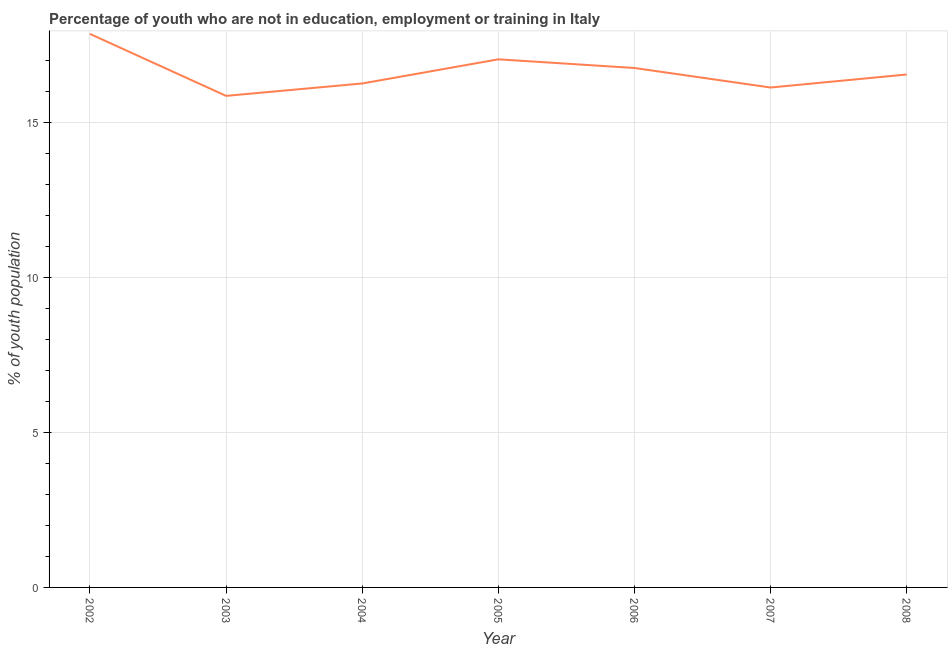What is the unemployed youth population in 2008?
Offer a very short reply. 16.56. Across all years, what is the maximum unemployed youth population?
Your answer should be compact. 17.87. Across all years, what is the minimum unemployed youth population?
Make the answer very short. 15.87. In which year was the unemployed youth population minimum?
Give a very brief answer. 2003. What is the sum of the unemployed youth population?
Offer a terse response. 116.53. What is the difference between the unemployed youth population in 2002 and 2005?
Your response must be concise. 0.82. What is the average unemployed youth population per year?
Give a very brief answer. 16.65. What is the median unemployed youth population?
Provide a succinct answer. 16.56. In how many years, is the unemployed youth population greater than 11 %?
Offer a very short reply. 7. Do a majority of the years between 2004 and 2002 (inclusive) have unemployed youth population greater than 11 %?
Ensure brevity in your answer.  No. What is the ratio of the unemployed youth population in 2005 to that in 2006?
Your response must be concise. 1.02. Is the unemployed youth population in 2005 less than that in 2007?
Keep it short and to the point. No. Is the difference between the unemployed youth population in 2002 and 2007 greater than the difference between any two years?
Keep it short and to the point. No. What is the difference between the highest and the second highest unemployed youth population?
Offer a very short reply. 0.82. Is the sum of the unemployed youth population in 2002 and 2006 greater than the maximum unemployed youth population across all years?
Provide a succinct answer. Yes. What is the difference between the highest and the lowest unemployed youth population?
Offer a very short reply. 2. How many lines are there?
Provide a short and direct response. 1. What is the difference between two consecutive major ticks on the Y-axis?
Provide a short and direct response. 5. What is the title of the graph?
Provide a succinct answer. Percentage of youth who are not in education, employment or training in Italy. What is the label or title of the Y-axis?
Keep it short and to the point. % of youth population. What is the % of youth population in 2002?
Give a very brief answer. 17.87. What is the % of youth population in 2003?
Ensure brevity in your answer.  15.87. What is the % of youth population of 2004?
Offer a terse response. 16.27. What is the % of youth population of 2005?
Ensure brevity in your answer.  17.05. What is the % of youth population in 2006?
Ensure brevity in your answer.  16.77. What is the % of youth population in 2007?
Ensure brevity in your answer.  16.14. What is the % of youth population of 2008?
Keep it short and to the point. 16.56. What is the difference between the % of youth population in 2002 and 2004?
Your answer should be very brief. 1.6. What is the difference between the % of youth population in 2002 and 2005?
Provide a short and direct response. 0.82. What is the difference between the % of youth population in 2002 and 2007?
Ensure brevity in your answer.  1.73. What is the difference between the % of youth population in 2002 and 2008?
Your answer should be very brief. 1.31. What is the difference between the % of youth population in 2003 and 2005?
Make the answer very short. -1.18. What is the difference between the % of youth population in 2003 and 2007?
Keep it short and to the point. -0.27. What is the difference between the % of youth population in 2003 and 2008?
Provide a short and direct response. -0.69. What is the difference between the % of youth population in 2004 and 2005?
Offer a very short reply. -0.78. What is the difference between the % of youth population in 2004 and 2007?
Offer a very short reply. 0.13. What is the difference between the % of youth population in 2004 and 2008?
Make the answer very short. -0.29. What is the difference between the % of youth population in 2005 and 2006?
Offer a very short reply. 0.28. What is the difference between the % of youth population in 2005 and 2007?
Your answer should be very brief. 0.91. What is the difference between the % of youth population in 2005 and 2008?
Offer a terse response. 0.49. What is the difference between the % of youth population in 2006 and 2007?
Keep it short and to the point. 0.63. What is the difference between the % of youth population in 2006 and 2008?
Provide a short and direct response. 0.21. What is the difference between the % of youth population in 2007 and 2008?
Ensure brevity in your answer.  -0.42. What is the ratio of the % of youth population in 2002 to that in 2003?
Your response must be concise. 1.13. What is the ratio of the % of youth population in 2002 to that in 2004?
Keep it short and to the point. 1.1. What is the ratio of the % of youth population in 2002 to that in 2005?
Provide a succinct answer. 1.05. What is the ratio of the % of youth population in 2002 to that in 2006?
Offer a very short reply. 1.07. What is the ratio of the % of youth population in 2002 to that in 2007?
Your answer should be compact. 1.11. What is the ratio of the % of youth population in 2002 to that in 2008?
Keep it short and to the point. 1.08. What is the ratio of the % of youth population in 2003 to that in 2006?
Your answer should be compact. 0.95. What is the ratio of the % of youth population in 2003 to that in 2008?
Ensure brevity in your answer.  0.96. What is the ratio of the % of youth population in 2004 to that in 2005?
Offer a terse response. 0.95. What is the ratio of the % of youth population in 2004 to that in 2007?
Ensure brevity in your answer.  1.01. What is the ratio of the % of youth population in 2004 to that in 2008?
Provide a succinct answer. 0.98. What is the ratio of the % of youth population in 2005 to that in 2007?
Offer a terse response. 1.06. What is the ratio of the % of youth population in 2005 to that in 2008?
Offer a terse response. 1.03. What is the ratio of the % of youth population in 2006 to that in 2007?
Give a very brief answer. 1.04. 